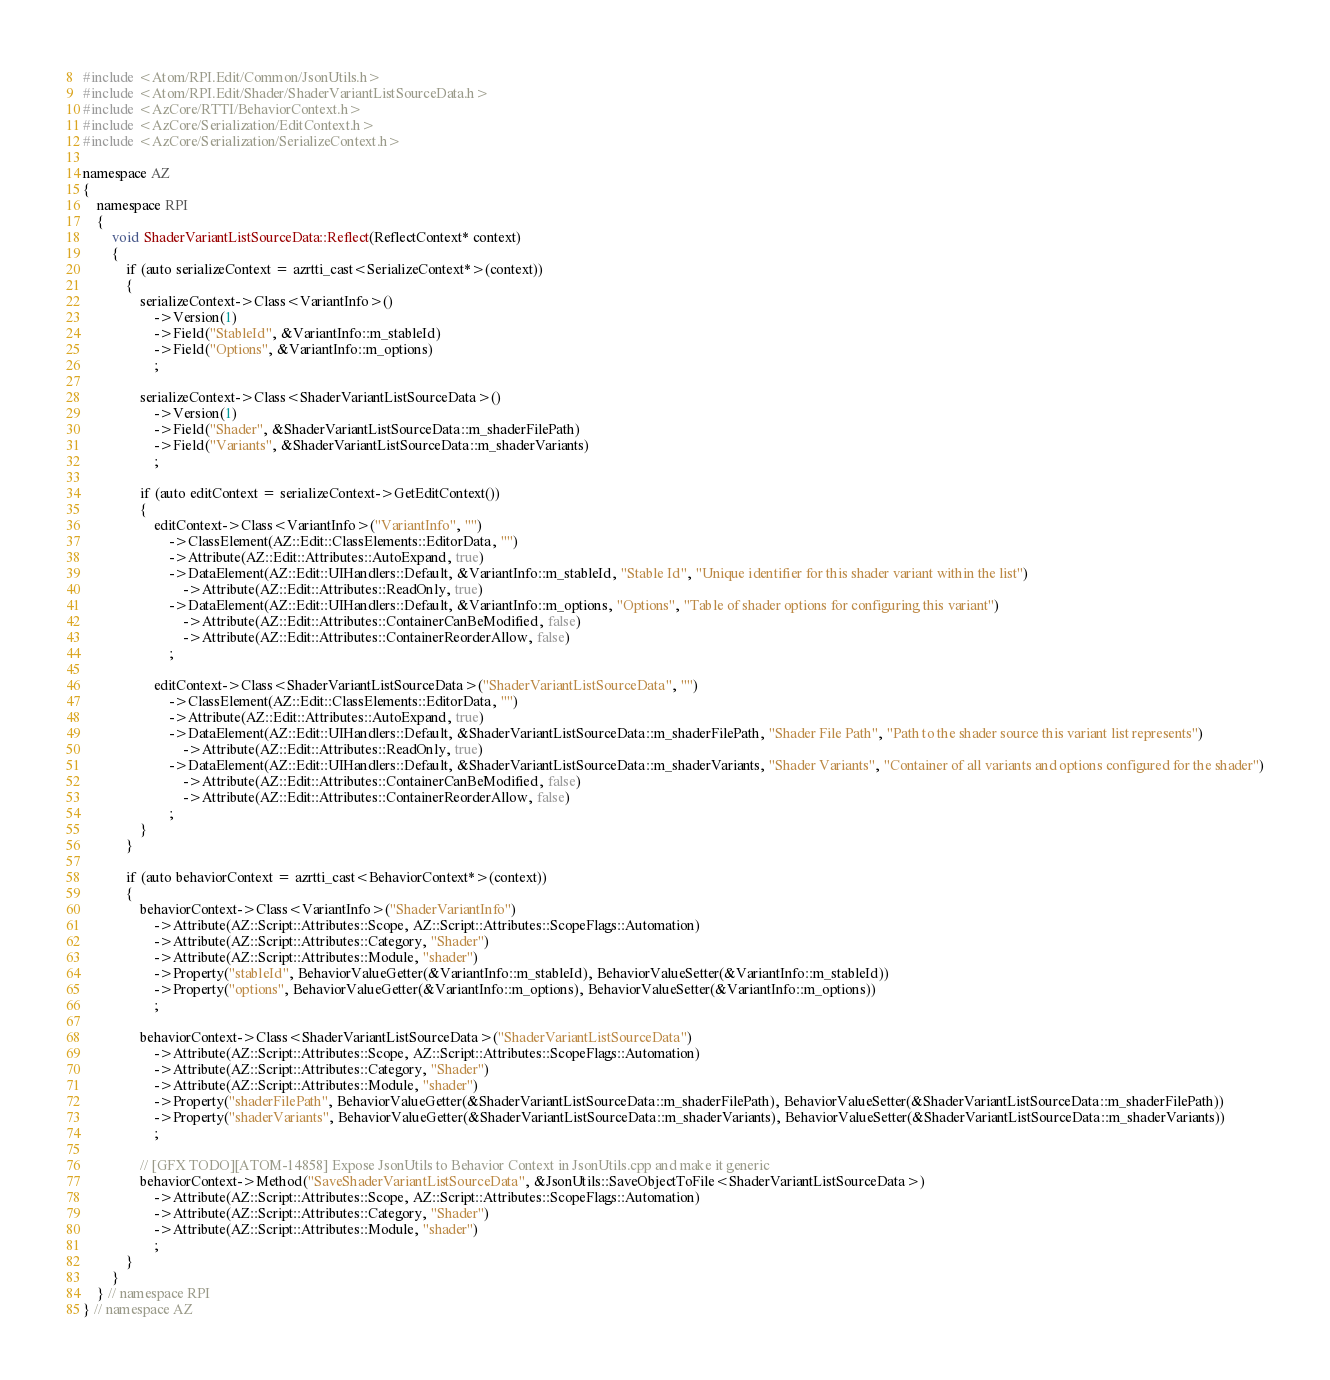Convert code to text. <code><loc_0><loc_0><loc_500><loc_500><_C++_>#include <Atom/RPI.Edit/Common/JsonUtils.h>
#include <Atom/RPI.Edit/Shader/ShaderVariantListSourceData.h>
#include <AzCore/RTTI/BehaviorContext.h>
#include <AzCore/Serialization/EditContext.h>
#include <AzCore/Serialization/SerializeContext.h>

namespace AZ
{
    namespace RPI
    {
        void ShaderVariantListSourceData::Reflect(ReflectContext* context)
        {
            if (auto serializeContext = azrtti_cast<SerializeContext*>(context))
            {
                serializeContext->Class<VariantInfo>()
                    ->Version(1)
                    ->Field("StableId", &VariantInfo::m_stableId)
                    ->Field("Options", &VariantInfo::m_options)
                    ;

                serializeContext->Class<ShaderVariantListSourceData>()
                    ->Version(1)
                    ->Field("Shader", &ShaderVariantListSourceData::m_shaderFilePath)
                    ->Field("Variants", &ShaderVariantListSourceData::m_shaderVariants)
                    ;

                if (auto editContext = serializeContext->GetEditContext())
                {
                    editContext->Class<VariantInfo>("VariantInfo", "")
                        ->ClassElement(AZ::Edit::ClassElements::EditorData, "")
                        ->Attribute(AZ::Edit::Attributes::AutoExpand, true)
                        ->DataElement(AZ::Edit::UIHandlers::Default, &VariantInfo::m_stableId, "Stable Id", "Unique identifier for this shader variant within the list")
                            ->Attribute(AZ::Edit::Attributes::ReadOnly, true)
                        ->DataElement(AZ::Edit::UIHandlers::Default, &VariantInfo::m_options, "Options", "Table of shader options for configuring this variant")
                            ->Attribute(AZ::Edit::Attributes::ContainerCanBeModified, false)
                            ->Attribute(AZ::Edit::Attributes::ContainerReorderAllow, false)
                        ;

                    editContext->Class<ShaderVariantListSourceData>("ShaderVariantListSourceData", "")
                        ->ClassElement(AZ::Edit::ClassElements::EditorData, "")
                        ->Attribute(AZ::Edit::Attributes::AutoExpand, true)
                        ->DataElement(AZ::Edit::UIHandlers::Default, &ShaderVariantListSourceData::m_shaderFilePath, "Shader File Path", "Path to the shader source this variant list represents")
                            ->Attribute(AZ::Edit::Attributes::ReadOnly, true)
                        ->DataElement(AZ::Edit::UIHandlers::Default, &ShaderVariantListSourceData::m_shaderVariants, "Shader Variants", "Container of all variants and options configured for the shader")
                            ->Attribute(AZ::Edit::Attributes::ContainerCanBeModified, false)
                            ->Attribute(AZ::Edit::Attributes::ContainerReorderAllow, false)
                        ;
                }
            }

            if (auto behaviorContext = azrtti_cast<BehaviorContext*>(context))
            {
                behaviorContext->Class<VariantInfo>("ShaderVariantInfo")
                    ->Attribute(AZ::Script::Attributes::Scope, AZ::Script::Attributes::ScopeFlags::Automation)
                    ->Attribute(AZ::Script::Attributes::Category, "Shader")
                    ->Attribute(AZ::Script::Attributes::Module, "shader")
                    ->Property("stableId", BehaviorValueGetter(&VariantInfo::m_stableId), BehaviorValueSetter(&VariantInfo::m_stableId))
                    ->Property("options", BehaviorValueGetter(&VariantInfo::m_options), BehaviorValueSetter(&VariantInfo::m_options))
                    ;

                behaviorContext->Class<ShaderVariantListSourceData>("ShaderVariantListSourceData")
                    ->Attribute(AZ::Script::Attributes::Scope, AZ::Script::Attributes::ScopeFlags::Automation)
                    ->Attribute(AZ::Script::Attributes::Category, "Shader")
                    ->Attribute(AZ::Script::Attributes::Module, "shader")
                    ->Property("shaderFilePath", BehaviorValueGetter(&ShaderVariantListSourceData::m_shaderFilePath), BehaviorValueSetter(&ShaderVariantListSourceData::m_shaderFilePath))
                    ->Property("shaderVariants", BehaviorValueGetter(&ShaderVariantListSourceData::m_shaderVariants), BehaviorValueSetter(&ShaderVariantListSourceData::m_shaderVariants))
                    ;

                // [GFX TODO][ATOM-14858] Expose JsonUtils to Behavior Context in JsonUtils.cpp and make it generic
                behaviorContext->Method("SaveShaderVariantListSourceData", &JsonUtils::SaveObjectToFile<ShaderVariantListSourceData>)
                    ->Attribute(AZ::Script::Attributes::Scope, AZ::Script::Attributes::ScopeFlags::Automation)
                    ->Attribute(AZ::Script::Attributes::Category, "Shader")
                    ->Attribute(AZ::Script::Attributes::Module, "shader")
                    ;
            }
        }
    } // namespace RPI
} // namespace AZ
</code> 